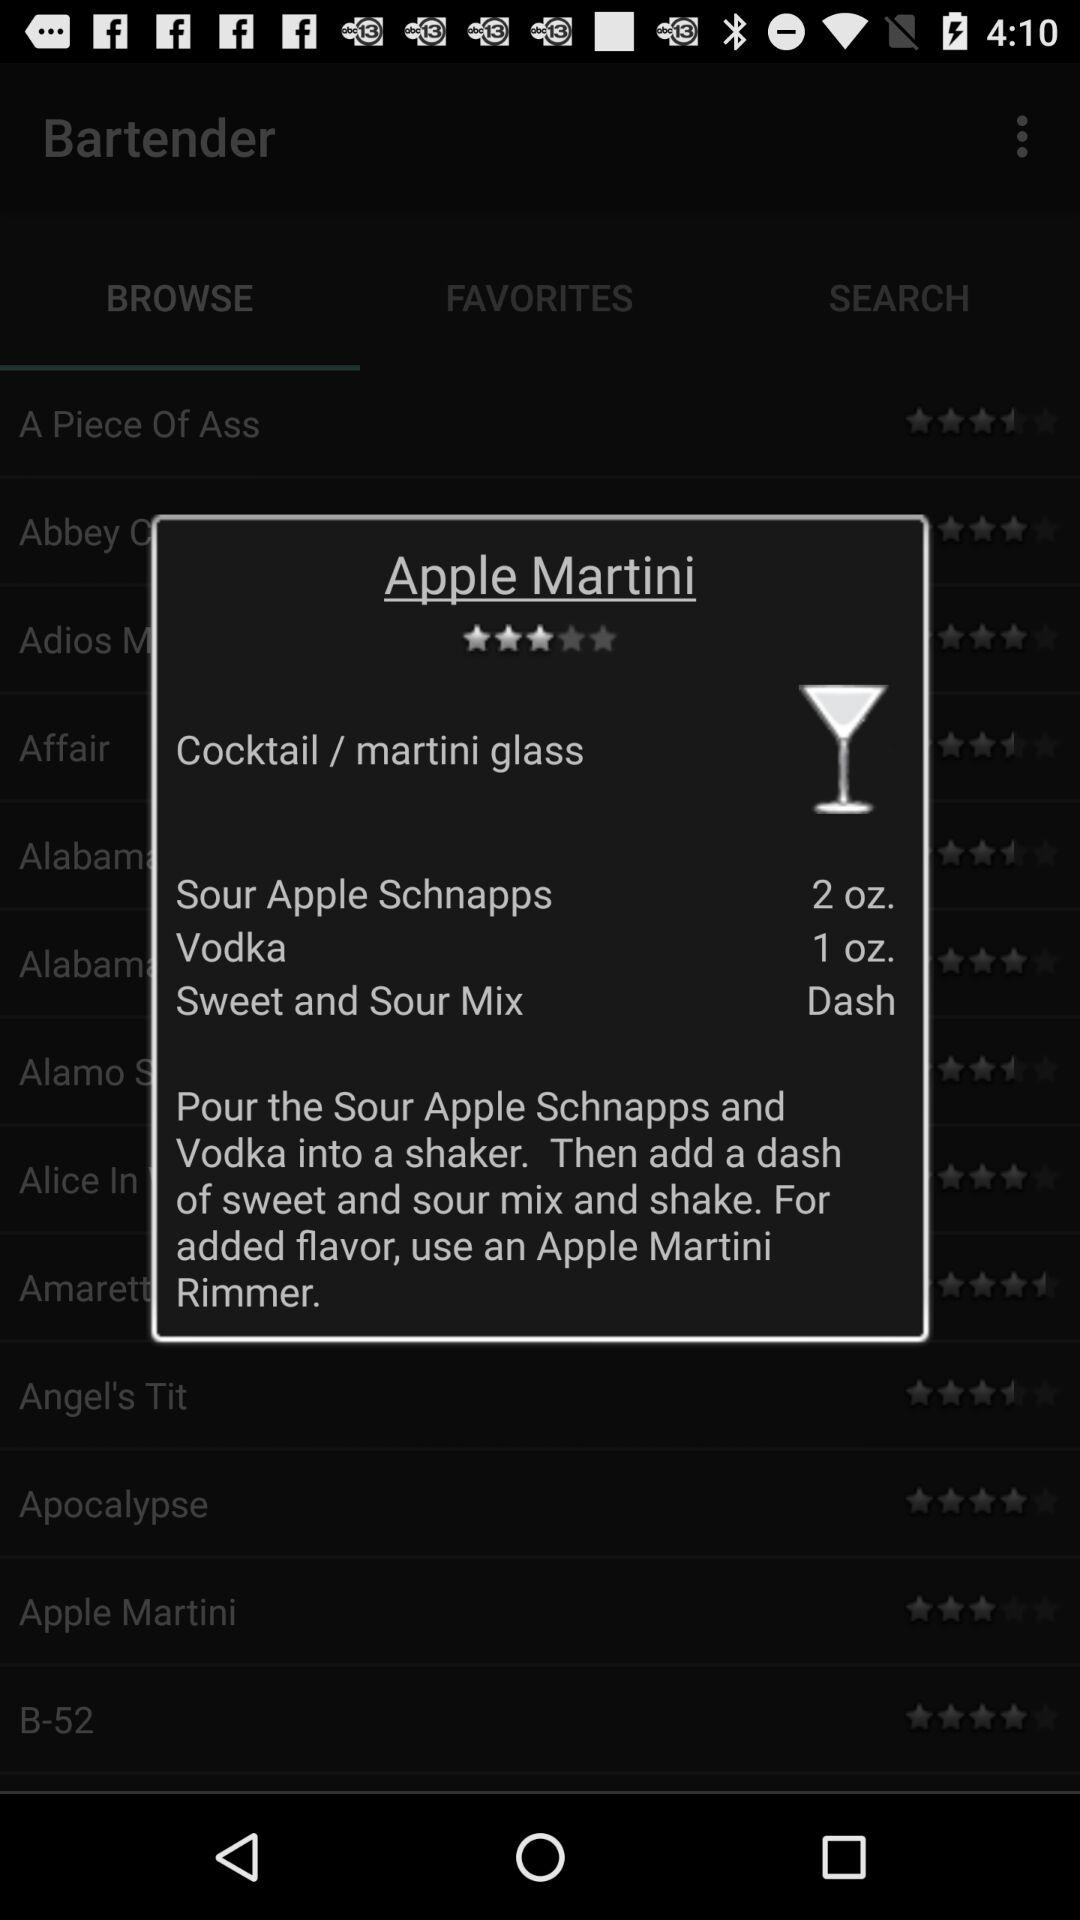What is the rating? The rating is 3 stars. 